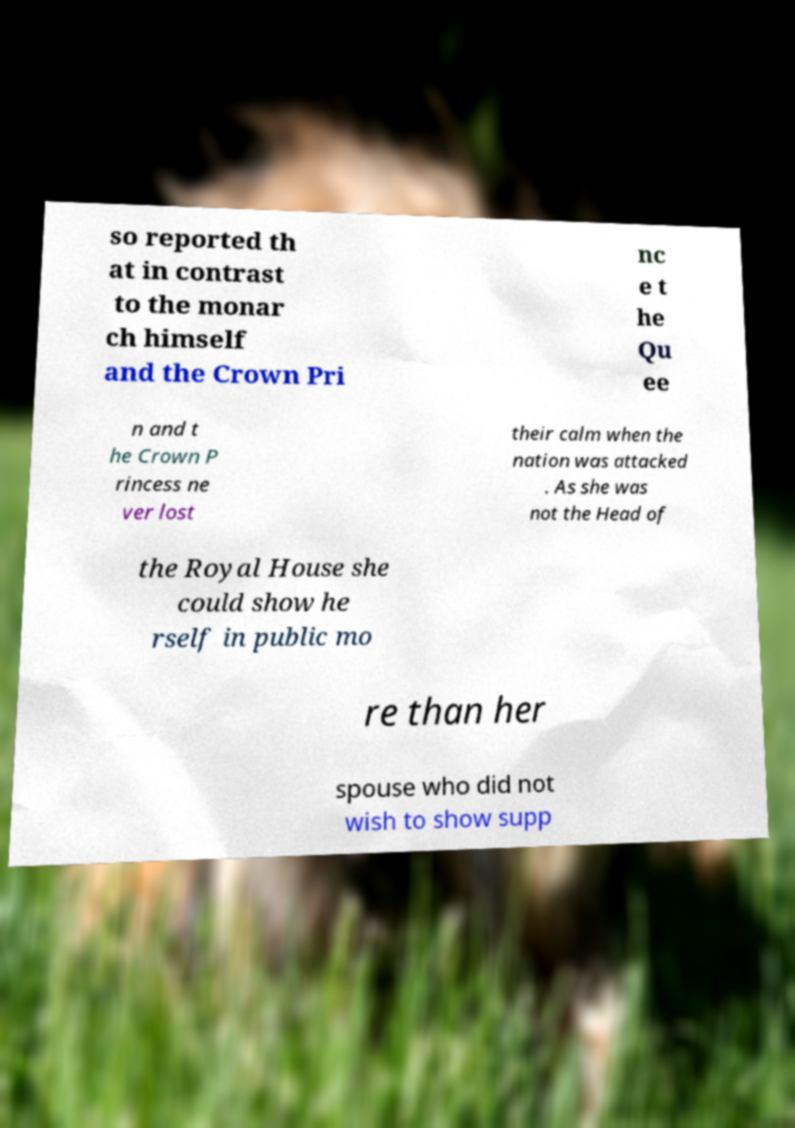Could you extract and type out the text from this image? so reported th at in contrast to the monar ch himself and the Crown Pri nc e t he Qu ee n and t he Crown P rincess ne ver lost their calm when the nation was attacked . As she was not the Head of the Royal House she could show he rself in public mo re than her spouse who did not wish to show supp 